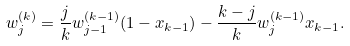<formula> <loc_0><loc_0><loc_500><loc_500>w _ { j } ^ { ( k ) } & = \frac { j } { k } w _ { j - 1 } ^ { ( k - 1 ) } ( 1 - x _ { k - 1 } ) - \frac { k - j } { k } w _ { j } ^ { ( k - 1 ) } x _ { k - 1 } .</formula> 